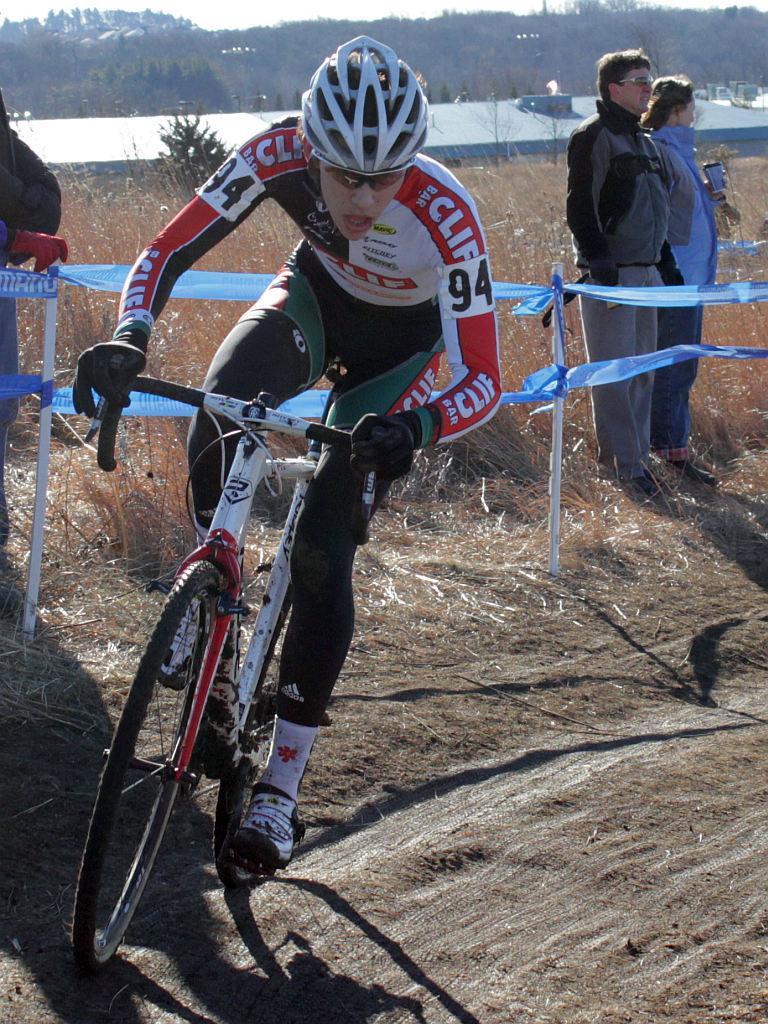In one or two sentences, can you explain what this image depicts? In the image we can see a person wearing clothes, gloves, shoes, helmet and the person is riding on the bicycle. Here we can see people standing and here we can see dry grass, water, trees and the sky. We can even see the poles and the tape attached to the poles. 